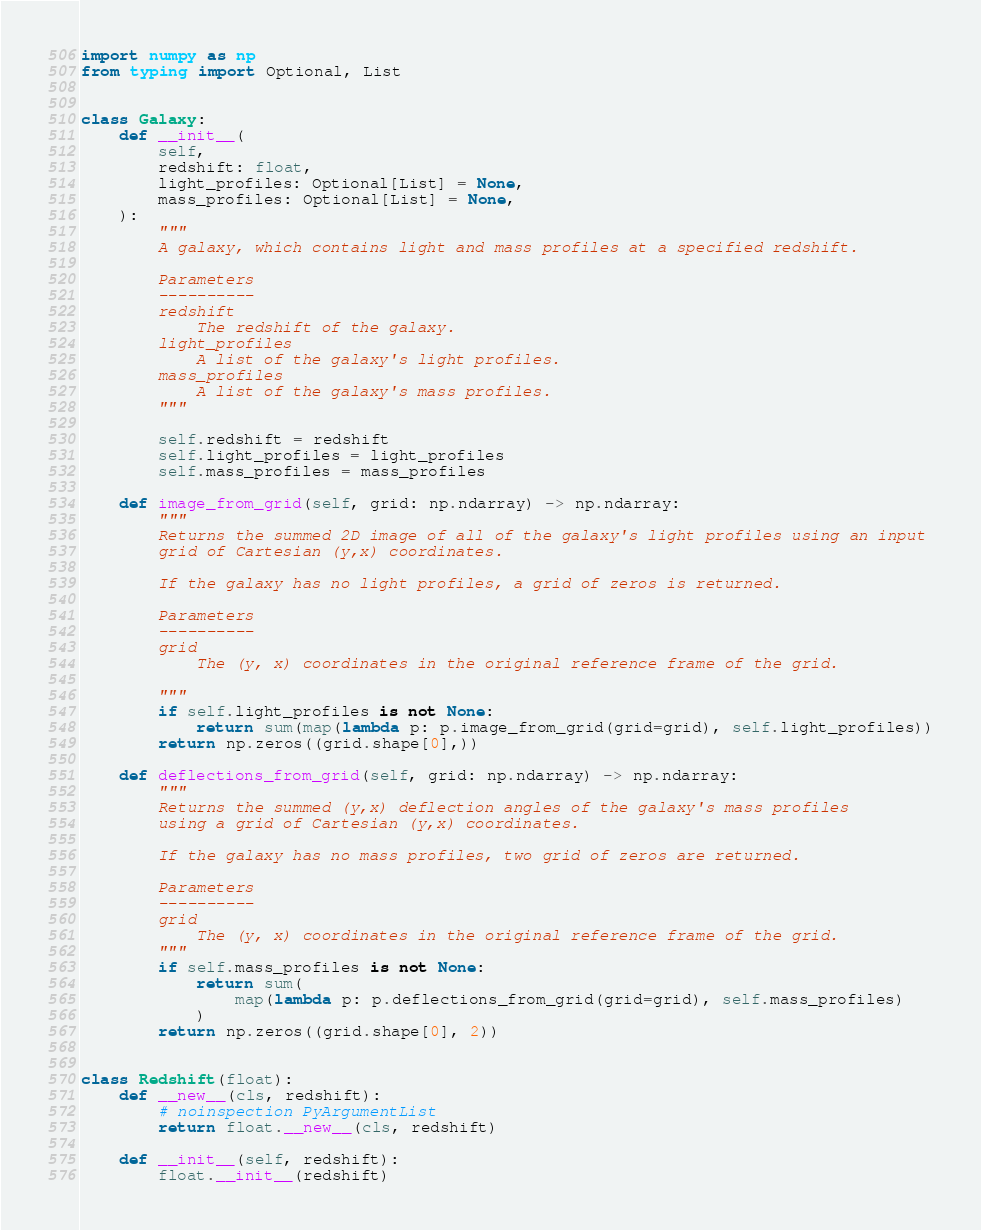<code> <loc_0><loc_0><loc_500><loc_500><_Python_>import numpy as np
from typing import Optional, List


class Galaxy:
    def __init__(
        self,
        redshift: float,
        light_profiles: Optional[List] = None,
        mass_profiles: Optional[List] = None,
    ):
        """
        A galaxy, which contains light and mass profiles at a specified redshift.

        Parameters
        ----------
        redshift
            The redshift of the galaxy.
        light_profiles
            A list of the galaxy's light profiles.
        mass_profiles
            A list of the galaxy's mass profiles.
        """

        self.redshift = redshift
        self.light_profiles = light_profiles
        self.mass_profiles = mass_profiles

    def image_from_grid(self, grid: np.ndarray) -> np.ndarray:
        """
        Returns the summed 2D image of all of the galaxy's light profiles using an input
        grid of Cartesian (y,x) coordinates.

        If the galaxy has no light profiles, a grid of zeros is returned.

        Parameters
        ----------
        grid
            The (y, x) coordinates in the original reference frame of the grid.

        """
        if self.light_profiles is not None:
            return sum(map(lambda p: p.image_from_grid(grid=grid), self.light_profiles))
        return np.zeros((grid.shape[0],))

    def deflections_from_grid(self, grid: np.ndarray) -> np.ndarray:
        """
        Returns the summed (y,x) deflection angles of the galaxy's mass profiles
        using a grid of Cartesian (y,x) coordinates.

        If the galaxy has no mass profiles, two grid of zeros are returned.

        Parameters
        ----------
        grid
            The (y, x) coordinates in the original reference frame of the grid.
        """
        if self.mass_profiles is not None:
            return sum(
                map(lambda p: p.deflections_from_grid(grid=grid), self.mass_profiles)
            )
        return np.zeros((grid.shape[0], 2))


class Redshift(float):
    def __new__(cls, redshift):
        # noinspection PyArgumentList
        return float.__new__(cls, redshift)

    def __init__(self, redshift):
        float.__init__(redshift)
</code> 